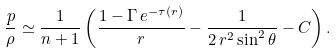Convert formula to latex. <formula><loc_0><loc_0><loc_500><loc_500>\frac { p } { \rho } \simeq \frac { 1 } { n + 1 } \left ( \frac { 1 - \Gamma \, e ^ { - \tau ( r ) } } { r } - \frac { 1 } { 2 \, r ^ { 2 } \sin ^ { 2 } \theta } - C \right ) .</formula> 